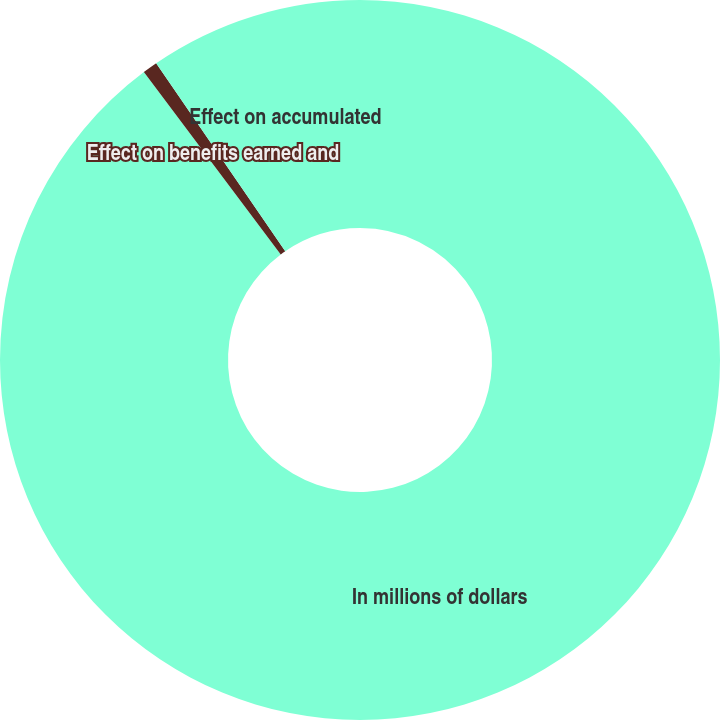Convert chart to OTSL. <chart><loc_0><loc_0><loc_500><loc_500><pie_chart><fcel>In millions of dollars<fcel>Effect on benefits earned and<fcel>Effect on accumulated<nl><fcel>89.76%<fcel>0.67%<fcel>9.58%<nl></chart> 